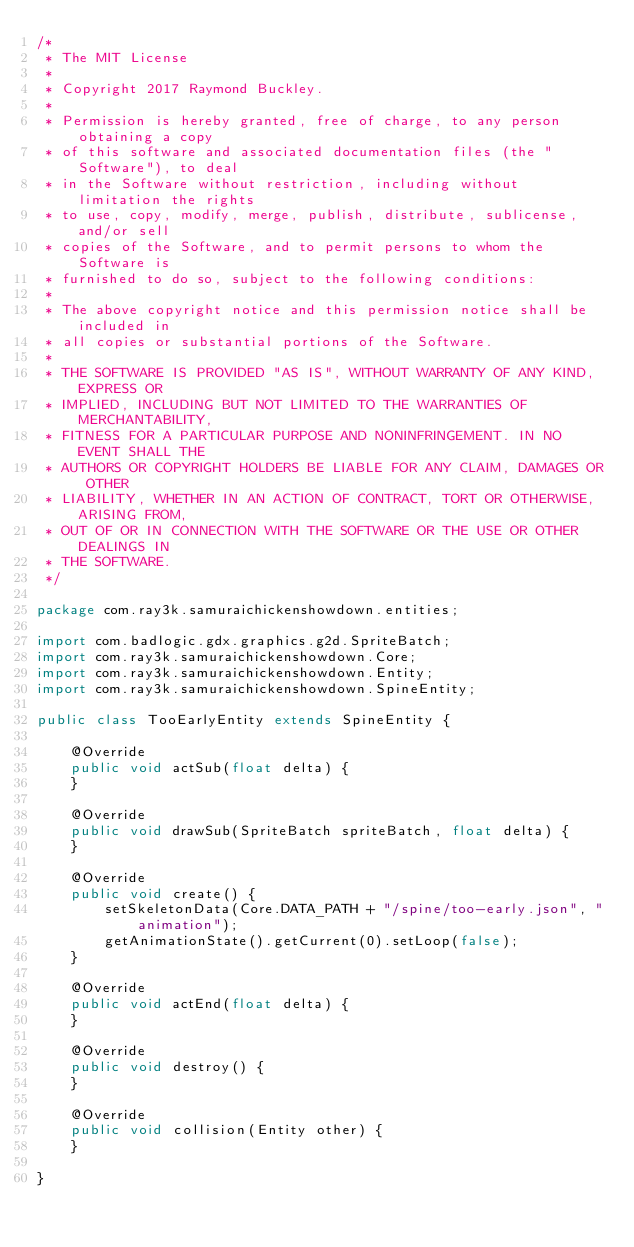<code> <loc_0><loc_0><loc_500><loc_500><_Java_>/*
 * The MIT License
 *
 * Copyright 2017 Raymond Buckley.
 *
 * Permission is hereby granted, free of charge, to any person obtaining a copy
 * of this software and associated documentation files (the "Software"), to deal
 * in the Software without restriction, including without limitation the rights
 * to use, copy, modify, merge, publish, distribute, sublicense, and/or sell
 * copies of the Software, and to permit persons to whom the Software is
 * furnished to do so, subject to the following conditions:
 *
 * The above copyright notice and this permission notice shall be included in
 * all copies or substantial portions of the Software.
 *
 * THE SOFTWARE IS PROVIDED "AS IS", WITHOUT WARRANTY OF ANY KIND, EXPRESS OR
 * IMPLIED, INCLUDING BUT NOT LIMITED TO THE WARRANTIES OF MERCHANTABILITY,
 * FITNESS FOR A PARTICULAR PURPOSE AND NONINFRINGEMENT. IN NO EVENT SHALL THE
 * AUTHORS OR COPYRIGHT HOLDERS BE LIABLE FOR ANY CLAIM, DAMAGES OR OTHER
 * LIABILITY, WHETHER IN AN ACTION OF CONTRACT, TORT OR OTHERWISE, ARISING FROM,
 * OUT OF OR IN CONNECTION WITH THE SOFTWARE OR THE USE OR OTHER DEALINGS IN
 * THE SOFTWARE.
 */

package com.ray3k.samuraichickenshowdown.entities;

import com.badlogic.gdx.graphics.g2d.SpriteBatch;
import com.ray3k.samuraichickenshowdown.Core;
import com.ray3k.samuraichickenshowdown.Entity;
import com.ray3k.samuraichickenshowdown.SpineEntity;

public class TooEarlyEntity extends SpineEntity {

    @Override
    public void actSub(float delta) {
    }

    @Override
    public void drawSub(SpriteBatch spriteBatch, float delta) {
    }

    @Override
    public void create() {
        setSkeletonData(Core.DATA_PATH + "/spine/too-early.json", "animation");
        getAnimationState().getCurrent(0).setLoop(false);
    }

    @Override
    public void actEnd(float delta) {
    }

    @Override
    public void destroy() {
    }

    @Override
    public void collision(Entity other) {
    }

}
</code> 